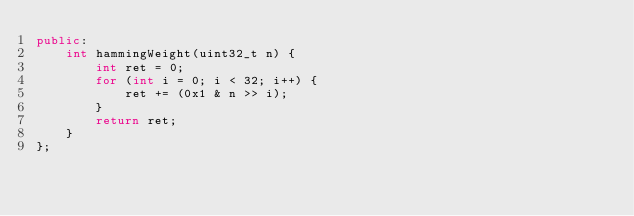<code> <loc_0><loc_0><loc_500><loc_500><_C++_>public:
    int hammingWeight(uint32_t n) {
        int ret = 0;
        for (int i = 0; i < 32; i++) {
            ret += (0x1 & n >> i);
        }
        return ret;
    }
};
</code> 